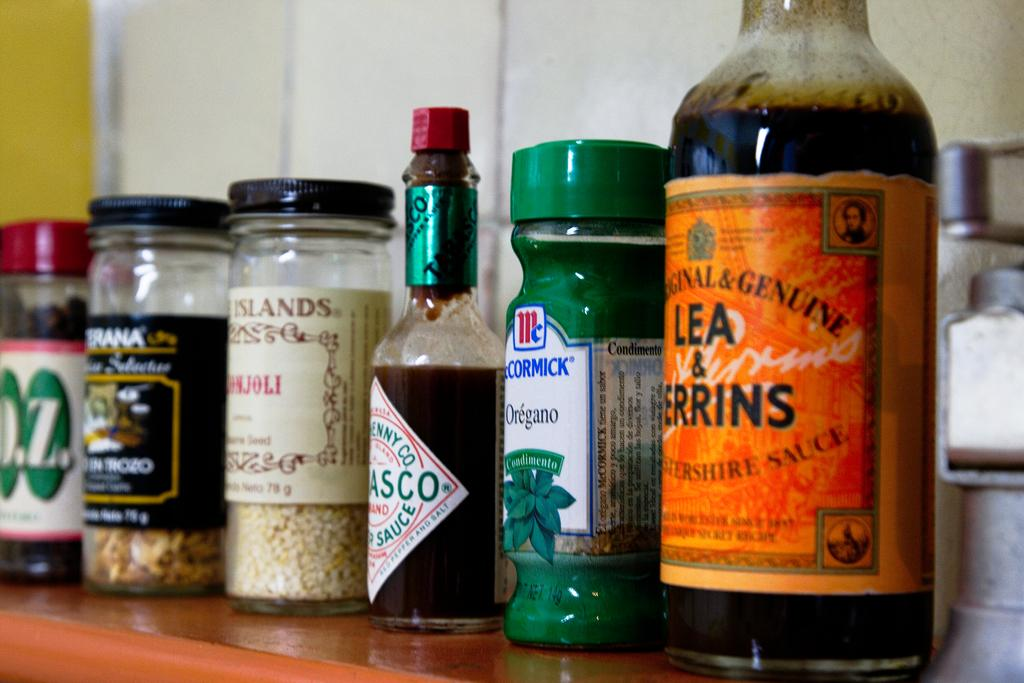Provide a one-sentence caption for the provided image. Lea & Perrins Worcestershire sauce sits on a shelf next to several other spices and seasonings. 